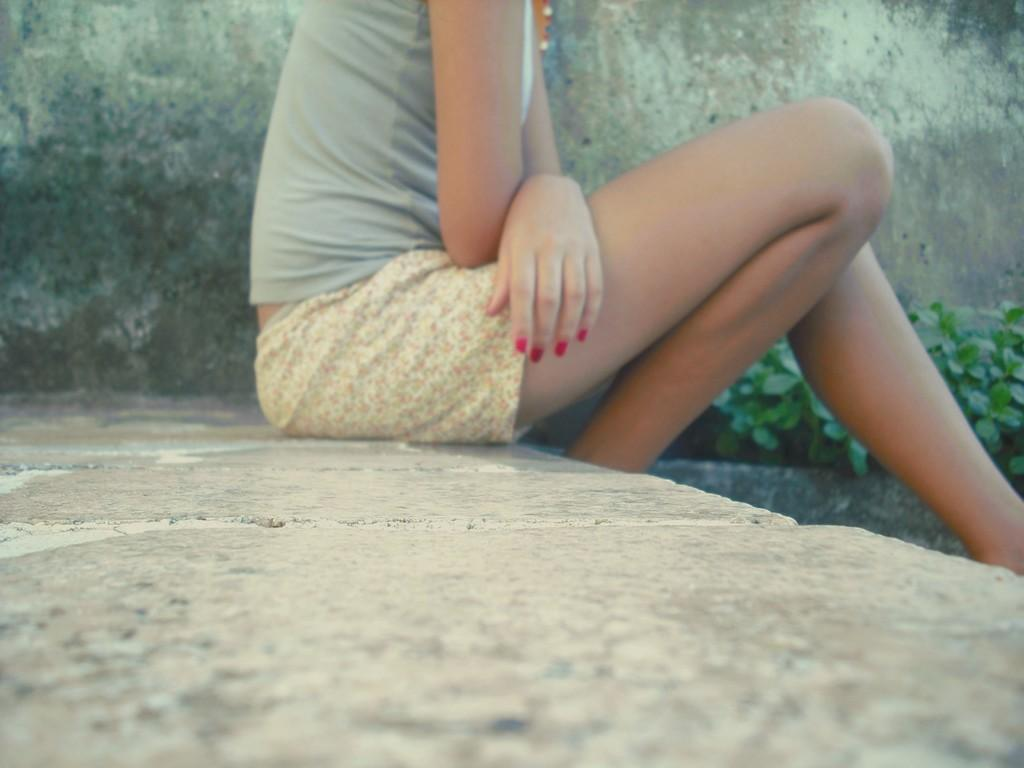What is the person in the image doing? The person is sitting on the wall in the image. What can be seen in the background of the image? There are plants in the background of the image. What type of bean is growing in the harbor in the image? There is no harbor or bean present in the image. What kind of cloud can be seen in the image? The image does not show any clouds; it only features a person sitting on a wall and plants in the background. 